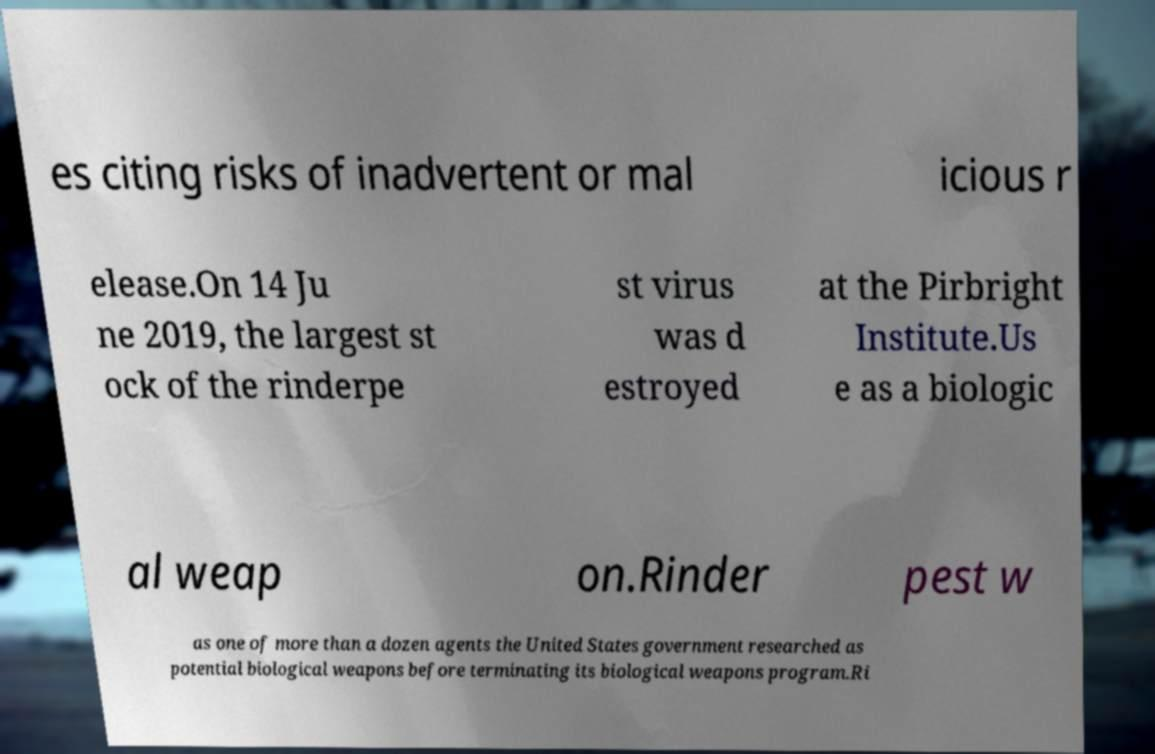Can you accurately transcribe the text from the provided image for me? es citing risks of inadvertent or mal icious r elease.On 14 Ju ne 2019, the largest st ock of the rinderpe st virus was d estroyed at the Pirbright Institute.Us e as a biologic al weap on.Rinder pest w as one of more than a dozen agents the United States government researched as potential biological weapons before terminating its biological weapons program.Ri 